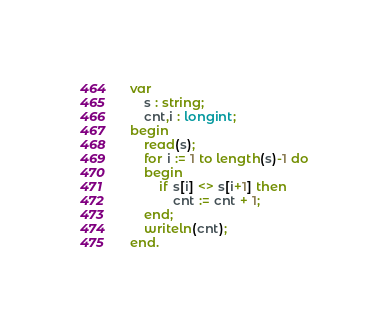<code> <loc_0><loc_0><loc_500><loc_500><_Pascal_>var
    s : string;
    cnt,i : longint;
begin
    read(s);
    for i := 1 to length(s)-1 do
    begin
        if s[i] <> s[i+1] then
            cnt := cnt + 1;
    end;
    writeln(cnt);
end.</code> 